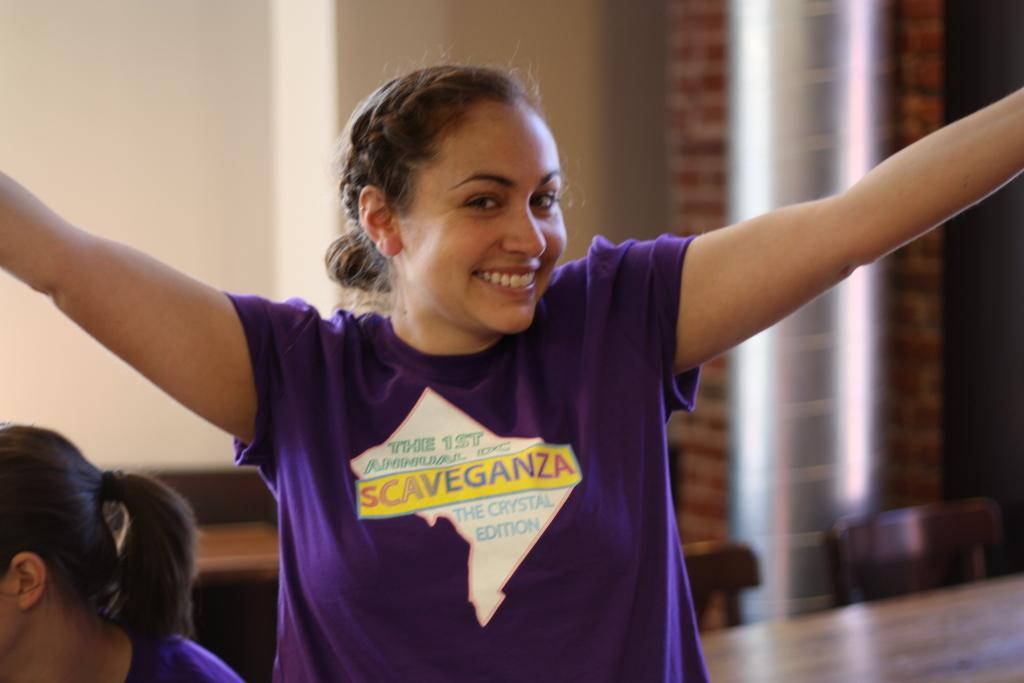What is the main subject of the image? There is a lady in the image. What is the lady wearing in the image? The lady is wearing a purple shirt in the image. What expression does the lady have in the image? The lady is smiling in the image. What type of toothbrush is the lady using in the image? There is no toothbrush present in the image; the lady is simply smiling. How much sugar is visible in the image? There is no sugar present in the image. 